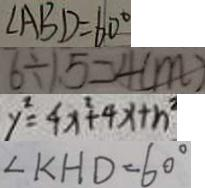<formula> <loc_0><loc_0><loc_500><loc_500>\angle A B D = 6 0 ^ { \circ } 
 6 \div 1 . 5 = 4 ( m ) 
 y ^ { 2 } = 4 x ^ { 2 } + 4 x + n ^ { 2 } 
 \angle K H D = 6 0 ^ { \circ }</formula> 